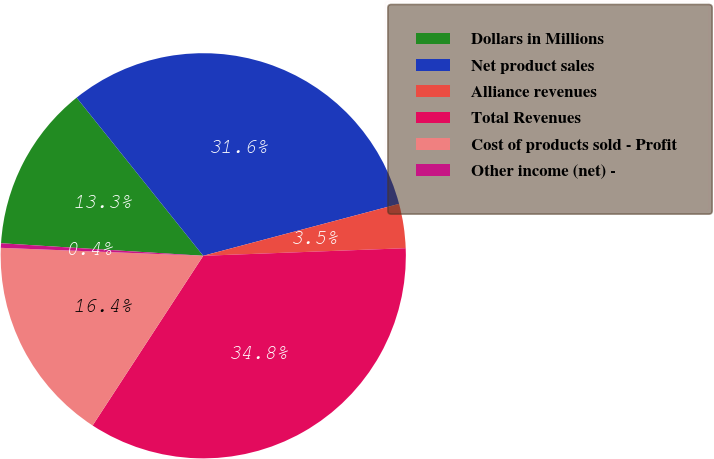<chart> <loc_0><loc_0><loc_500><loc_500><pie_chart><fcel>Dollars in Millions<fcel>Net product sales<fcel>Alliance revenues<fcel>Total Revenues<fcel>Cost of products sold - Profit<fcel>Other income (net) -<nl><fcel>13.27%<fcel>31.62%<fcel>3.53%<fcel>34.79%<fcel>16.43%<fcel>0.36%<nl></chart> 